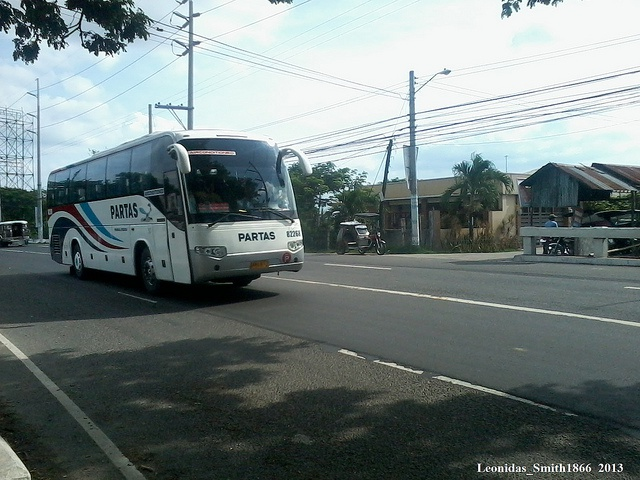Describe the objects in this image and their specific colors. I can see bus in gray, black, and blue tones, bench in gray, black, and darkgray tones, motorcycle in gray, black, and darkgray tones, motorcycle in gray, black, purple, and darkgray tones, and motorcycle in gray, black, and purple tones in this image. 